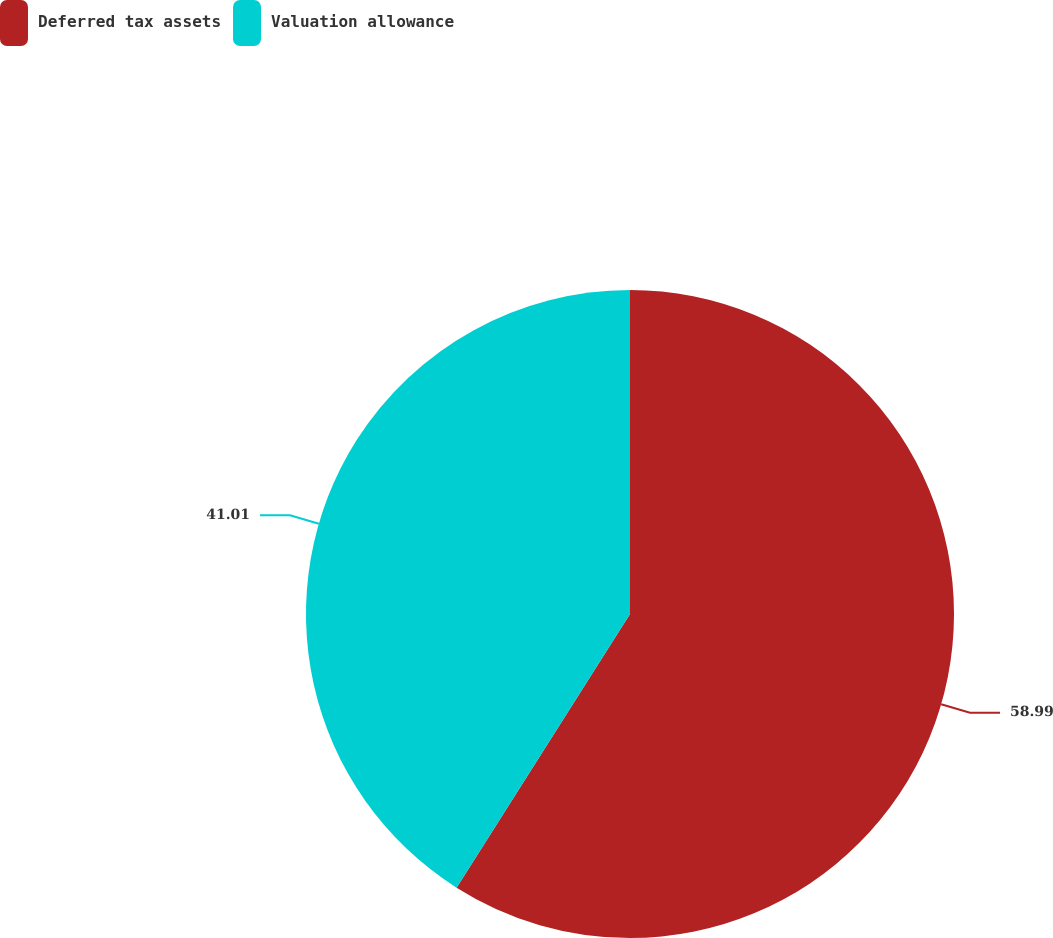<chart> <loc_0><loc_0><loc_500><loc_500><pie_chart><fcel>Deferred tax assets<fcel>Valuation allowance<nl><fcel>58.99%<fcel>41.01%<nl></chart> 